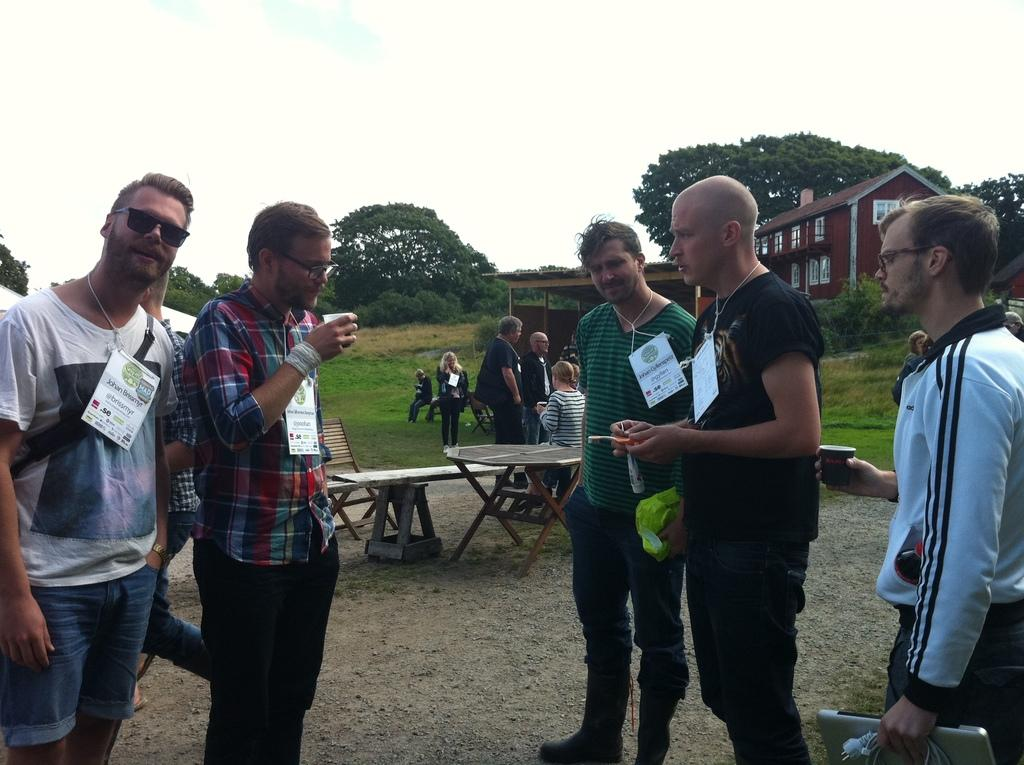What is the main subject of the image? The main subject of the image is a group of people standing on the ground. Where is the group of people located in relation to other objects in the image? The group of people is in front of a table. What type of natural environment is visible in the image? There are trees visible in the image. What type of structure can be seen in the background? There is a house in the image. What type of steel is used to construct the person in the image? There is no person made of steel in the image; it features a group of people standing on the ground. How is the glue being used by the trees in the image? There is no glue present in the image, and the trees are not using any glue. 